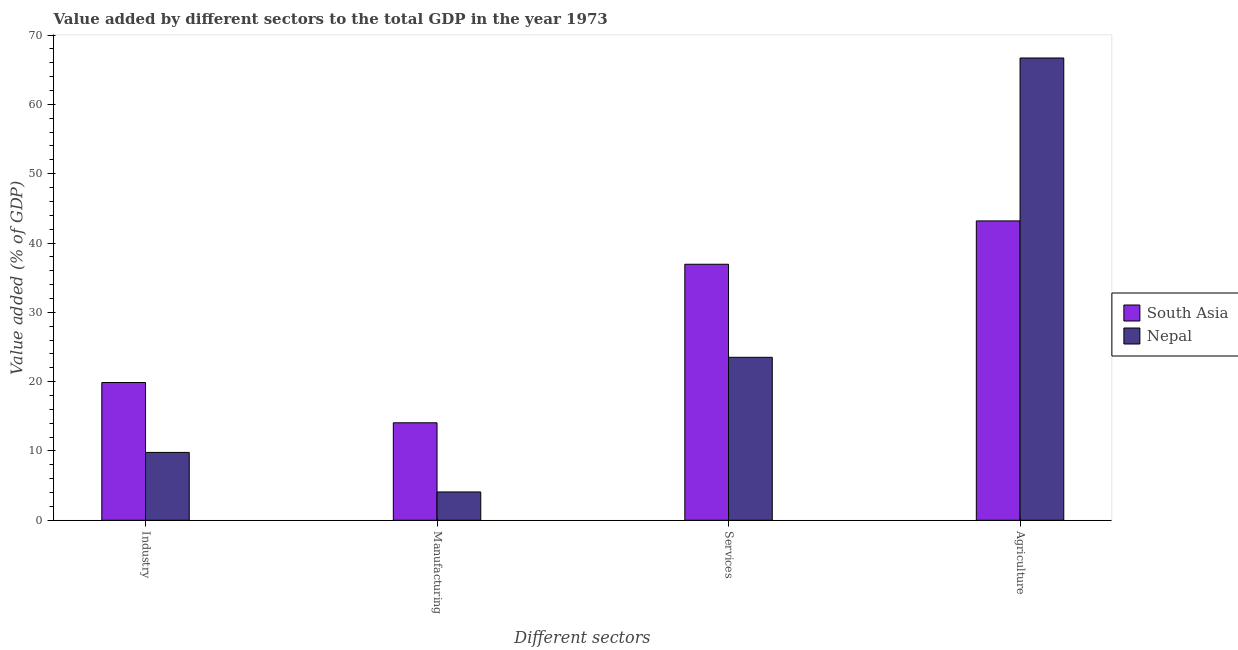How many groups of bars are there?
Provide a succinct answer. 4. Are the number of bars per tick equal to the number of legend labels?
Your answer should be very brief. Yes. How many bars are there on the 4th tick from the right?
Offer a very short reply. 2. What is the label of the 3rd group of bars from the left?
Provide a short and direct response. Services. What is the value added by agricultural sector in Nepal?
Your answer should be very brief. 66.7. Across all countries, what is the maximum value added by services sector?
Provide a succinct answer. 36.94. Across all countries, what is the minimum value added by manufacturing sector?
Offer a very short reply. 4.09. In which country was the value added by manufacturing sector maximum?
Provide a short and direct response. South Asia. In which country was the value added by industrial sector minimum?
Your response must be concise. Nepal. What is the total value added by manufacturing sector in the graph?
Ensure brevity in your answer.  18.15. What is the difference between the value added by manufacturing sector in Nepal and that in South Asia?
Offer a very short reply. -9.98. What is the difference between the value added by industrial sector in Nepal and the value added by agricultural sector in South Asia?
Your answer should be compact. -33.4. What is the average value added by agricultural sector per country?
Provide a succinct answer. 54.94. What is the difference between the value added by agricultural sector and value added by services sector in South Asia?
Provide a succinct answer. 6.25. What is the ratio of the value added by manufacturing sector in Nepal to that in South Asia?
Offer a terse response. 0.29. Is the difference between the value added by agricultural sector in Nepal and South Asia greater than the difference between the value added by industrial sector in Nepal and South Asia?
Your answer should be very brief. Yes. What is the difference between the highest and the second highest value added by services sector?
Give a very brief answer. 13.42. What is the difference between the highest and the lowest value added by manufacturing sector?
Make the answer very short. 9.98. In how many countries, is the value added by manufacturing sector greater than the average value added by manufacturing sector taken over all countries?
Your answer should be very brief. 1. What does the 2nd bar from the left in Industry represents?
Give a very brief answer. Nepal. What does the 1st bar from the right in Services represents?
Keep it short and to the point. Nepal. How many countries are there in the graph?
Your answer should be very brief. 2. What is the difference between two consecutive major ticks on the Y-axis?
Give a very brief answer. 10. Are the values on the major ticks of Y-axis written in scientific E-notation?
Provide a succinct answer. No. Does the graph contain grids?
Your answer should be very brief. No. What is the title of the graph?
Ensure brevity in your answer.  Value added by different sectors to the total GDP in the year 1973. What is the label or title of the X-axis?
Give a very brief answer. Different sectors. What is the label or title of the Y-axis?
Your answer should be very brief. Value added (% of GDP). What is the Value added (% of GDP) in South Asia in Industry?
Your answer should be very brief. 19.87. What is the Value added (% of GDP) in Nepal in Industry?
Your answer should be very brief. 9.79. What is the Value added (% of GDP) of South Asia in Manufacturing?
Provide a short and direct response. 14.06. What is the Value added (% of GDP) of Nepal in Manufacturing?
Offer a terse response. 4.09. What is the Value added (% of GDP) of South Asia in Services?
Your response must be concise. 36.94. What is the Value added (% of GDP) of Nepal in Services?
Your response must be concise. 23.51. What is the Value added (% of GDP) in South Asia in Agriculture?
Ensure brevity in your answer.  43.19. What is the Value added (% of GDP) in Nepal in Agriculture?
Your answer should be compact. 66.7. Across all Different sectors, what is the maximum Value added (% of GDP) of South Asia?
Ensure brevity in your answer.  43.19. Across all Different sectors, what is the maximum Value added (% of GDP) in Nepal?
Keep it short and to the point. 66.7. Across all Different sectors, what is the minimum Value added (% of GDP) of South Asia?
Your response must be concise. 14.06. Across all Different sectors, what is the minimum Value added (% of GDP) of Nepal?
Your answer should be very brief. 4.09. What is the total Value added (% of GDP) in South Asia in the graph?
Offer a very short reply. 114.06. What is the total Value added (% of GDP) in Nepal in the graph?
Make the answer very short. 104.09. What is the difference between the Value added (% of GDP) in South Asia in Industry and that in Manufacturing?
Keep it short and to the point. 5.81. What is the difference between the Value added (% of GDP) of Nepal in Industry and that in Manufacturing?
Your response must be concise. 5.7. What is the difference between the Value added (% of GDP) of South Asia in Industry and that in Services?
Keep it short and to the point. -17.06. What is the difference between the Value added (% of GDP) of Nepal in Industry and that in Services?
Provide a short and direct response. -13.72. What is the difference between the Value added (% of GDP) in South Asia in Industry and that in Agriculture?
Give a very brief answer. -23.32. What is the difference between the Value added (% of GDP) in Nepal in Industry and that in Agriculture?
Keep it short and to the point. -56.91. What is the difference between the Value added (% of GDP) of South Asia in Manufacturing and that in Services?
Make the answer very short. -22.87. What is the difference between the Value added (% of GDP) in Nepal in Manufacturing and that in Services?
Give a very brief answer. -19.43. What is the difference between the Value added (% of GDP) in South Asia in Manufacturing and that in Agriculture?
Provide a succinct answer. -29.13. What is the difference between the Value added (% of GDP) of Nepal in Manufacturing and that in Agriculture?
Your answer should be very brief. -62.61. What is the difference between the Value added (% of GDP) of South Asia in Services and that in Agriculture?
Offer a terse response. -6.25. What is the difference between the Value added (% of GDP) of Nepal in Services and that in Agriculture?
Keep it short and to the point. -43.18. What is the difference between the Value added (% of GDP) of South Asia in Industry and the Value added (% of GDP) of Nepal in Manufacturing?
Provide a short and direct response. 15.79. What is the difference between the Value added (% of GDP) in South Asia in Industry and the Value added (% of GDP) in Nepal in Services?
Ensure brevity in your answer.  -3.64. What is the difference between the Value added (% of GDP) of South Asia in Industry and the Value added (% of GDP) of Nepal in Agriculture?
Provide a short and direct response. -46.82. What is the difference between the Value added (% of GDP) of South Asia in Manufacturing and the Value added (% of GDP) of Nepal in Services?
Offer a terse response. -9.45. What is the difference between the Value added (% of GDP) of South Asia in Manufacturing and the Value added (% of GDP) of Nepal in Agriculture?
Your answer should be very brief. -52.63. What is the difference between the Value added (% of GDP) of South Asia in Services and the Value added (% of GDP) of Nepal in Agriculture?
Ensure brevity in your answer.  -29.76. What is the average Value added (% of GDP) of South Asia per Different sectors?
Your answer should be compact. 28.52. What is the average Value added (% of GDP) of Nepal per Different sectors?
Offer a very short reply. 26.02. What is the difference between the Value added (% of GDP) of South Asia and Value added (% of GDP) of Nepal in Industry?
Provide a short and direct response. 10.08. What is the difference between the Value added (% of GDP) in South Asia and Value added (% of GDP) in Nepal in Manufacturing?
Ensure brevity in your answer.  9.98. What is the difference between the Value added (% of GDP) in South Asia and Value added (% of GDP) in Nepal in Services?
Keep it short and to the point. 13.42. What is the difference between the Value added (% of GDP) in South Asia and Value added (% of GDP) in Nepal in Agriculture?
Provide a succinct answer. -23.51. What is the ratio of the Value added (% of GDP) in South Asia in Industry to that in Manufacturing?
Your answer should be compact. 1.41. What is the ratio of the Value added (% of GDP) of Nepal in Industry to that in Manufacturing?
Keep it short and to the point. 2.4. What is the ratio of the Value added (% of GDP) of South Asia in Industry to that in Services?
Your answer should be very brief. 0.54. What is the ratio of the Value added (% of GDP) in Nepal in Industry to that in Services?
Give a very brief answer. 0.42. What is the ratio of the Value added (% of GDP) of South Asia in Industry to that in Agriculture?
Offer a very short reply. 0.46. What is the ratio of the Value added (% of GDP) in Nepal in Industry to that in Agriculture?
Your response must be concise. 0.15. What is the ratio of the Value added (% of GDP) of South Asia in Manufacturing to that in Services?
Your response must be concise. 0.38. What is the ratio of the Value added (% of GDP) of Nepal in Manufacturing to that in Services?
Ensure brevity in your answer.  0.17. What is the ratio of the Value added (% of GDP) of South Asia in Manufacturing to that in Agriculture?
Offer a very short reply. 0.33. What is the ratio of the Value added (% of GDP) in Nepal in Manufacturing to that in Agriculture?
Offer a very short reply. 0.06. What is the ratio of the Value added (% of GDP) of South Asia in Services to that in Agriculture?
Provide a succinct answer. 0.86. What is the ratio of the Value added (% of GDP) in Nepal in Services to that in Agriculture?
Keep it short and to the point. 0.35. What is the difference between the highest and the second highest Value added (% of GDP) of South Asia?
Ensure brevity in your answer.  6.25. What is the difference between the highest and the second highest Value added (% of GDP) in Nepal?
Offer a very short reply. 43.18. What is the difference between the highest and the lowest Value added (% of GDP) in South Asia?
Provide a short and direct response. 29.13. What is the difference between the highest and the lowest Value added (% of GDP) in Nepal?
Make the answer very short. 62.61. 